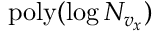Convert formula to latex. <formula><loc_0><loc_0><loc_500><loc_500>p o l y ( \log N _ { v _ { x } } )</formula> 